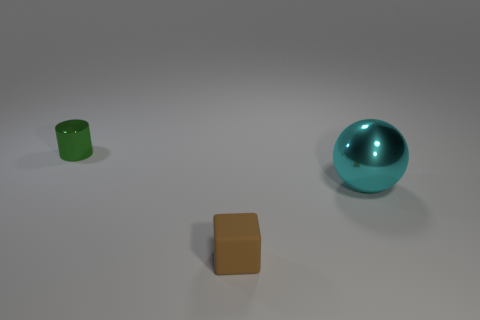Are there more matte cubes than big yellow metal spheres? Indeed, there are more matte cubes, as there is one visible in the image, and there are no big yellow metal spheres at all. 